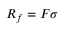Convert formula to latex. <formula><loc_0><loc_0><loc_500><loc_500>R _ { f } = F \sigma</formula> 